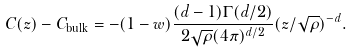<formula> <loc_0><loc_0><loc_500><loc_500>C ( z ) - C _ { \text {bulk} } = - ( 1 - w ) \frac { ( d - 1 ) \Gamma ( d / 2 ) } { 2 \sqrt { \rho } ( 4 \pi ) ^ { d / 2 } } ( z / \sqrt { \rho } ) ^ { - d } .</formula> 